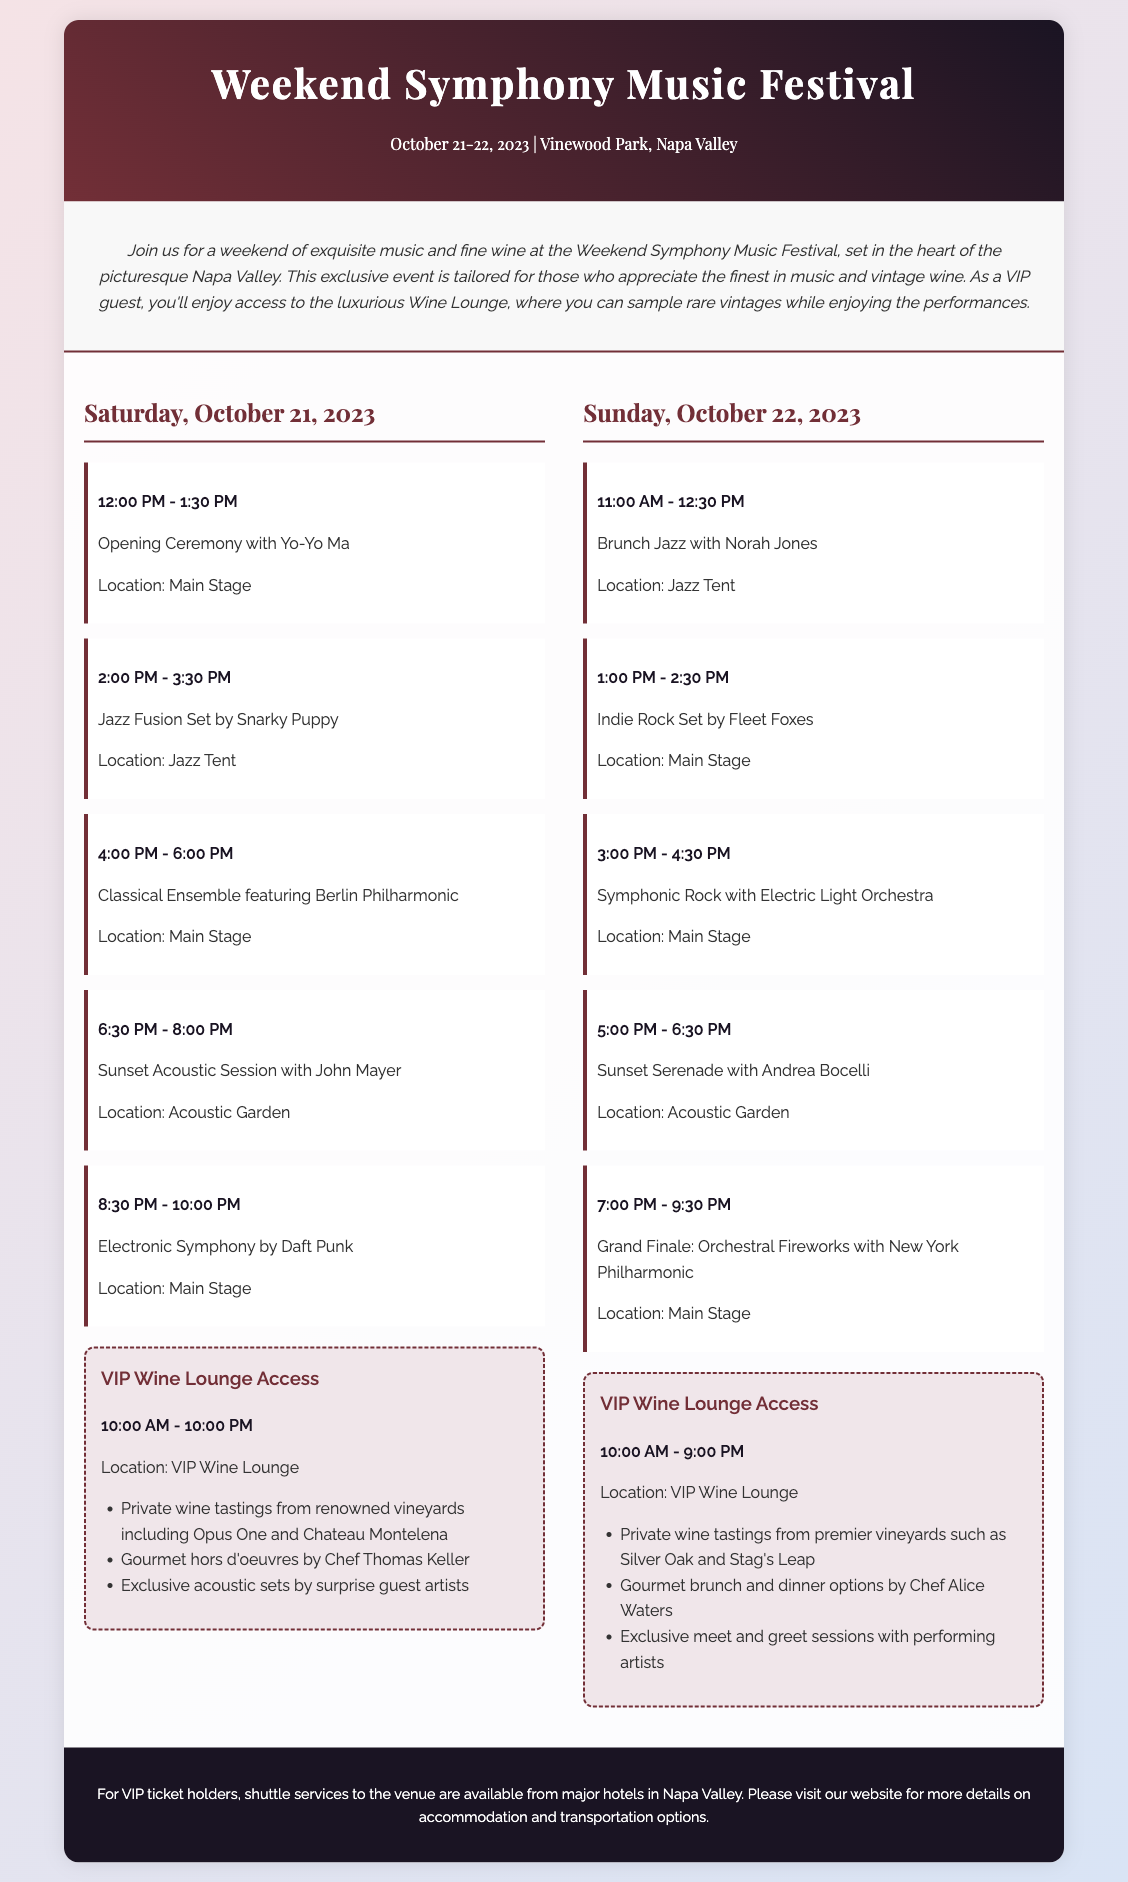What are the festival dates? The festival dates are stated at the top of the document, specifying the event duration.
Answer: October 21-22, 2023 Who is performing at the opening ceremony? The opening ceremony event lists the artist performing during this time.
Answer: Yo-Yo Ma What time does the VIP Wine Lounge open on Saturday? The opening time for the VIP Wine Lounge is provided in the VIP section for Saturday.
Answer: 10:00 AM Which artist is performing the Grand Finale? The Grand Finale event specifies the artist leading the performance at this time.
Answer: New York Philharmonic How long is the Sunset Acoustic Session? The duration of the Sunset Acoustic Session is given in the event description.
Answer: 1.5 hours What location hosts the brunch jazz performance? The location for the brunch jazz performance is indicated under the event details.
Answer: Jazz Tent What is included in the VIP experience on Sunday? The VIP section outlines specific experiences available for guests, which is summarized.
Answer: Private wine tastings, gourmet brunch, meet and greet What is the genre of the performance by Snarky Puppy? The performance genre for Snarky Puppy is specified in the document under their event details.
Answer: Jazz Fusion How many performances happen on Saturday? The number of performances can be counted from the Saturday events listed in the schedule.
Answer: Five 